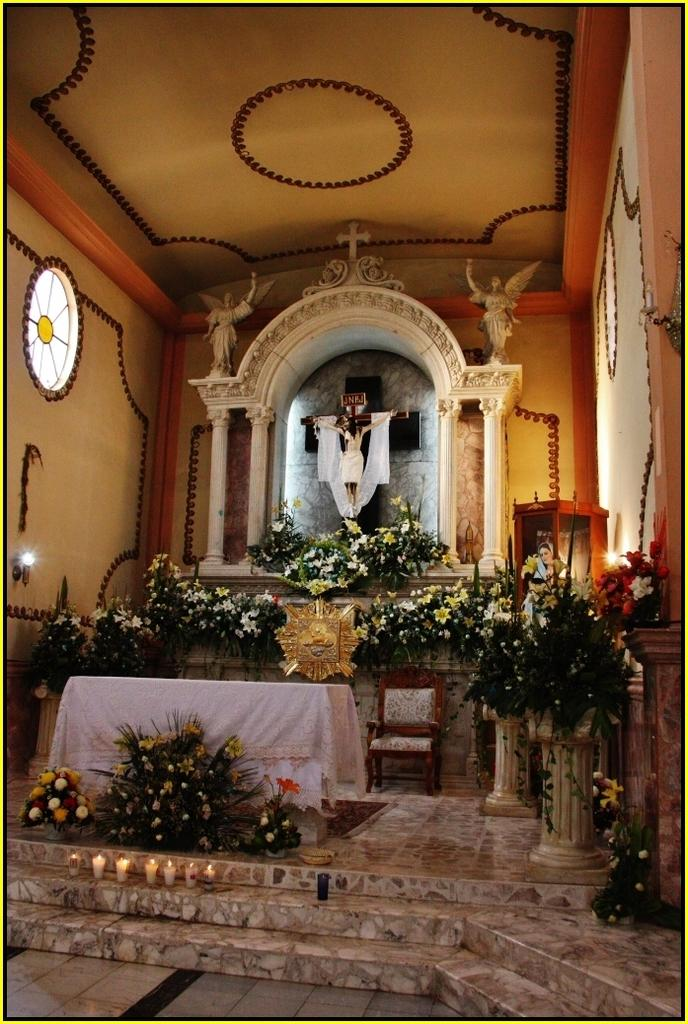What type of plants can be seen in the image? There are plants with flowers in the image. What other objects or features are present in the image? There are sculptures, a holy cross symbol, a table, a chair, and lights in the image. Can you tell me the account number of the cactus in the image? There is no cactus present in the image, and therefore no account number can be associated with it. Is there a skateboard visible in the image? There is no skateboard present in the image. 